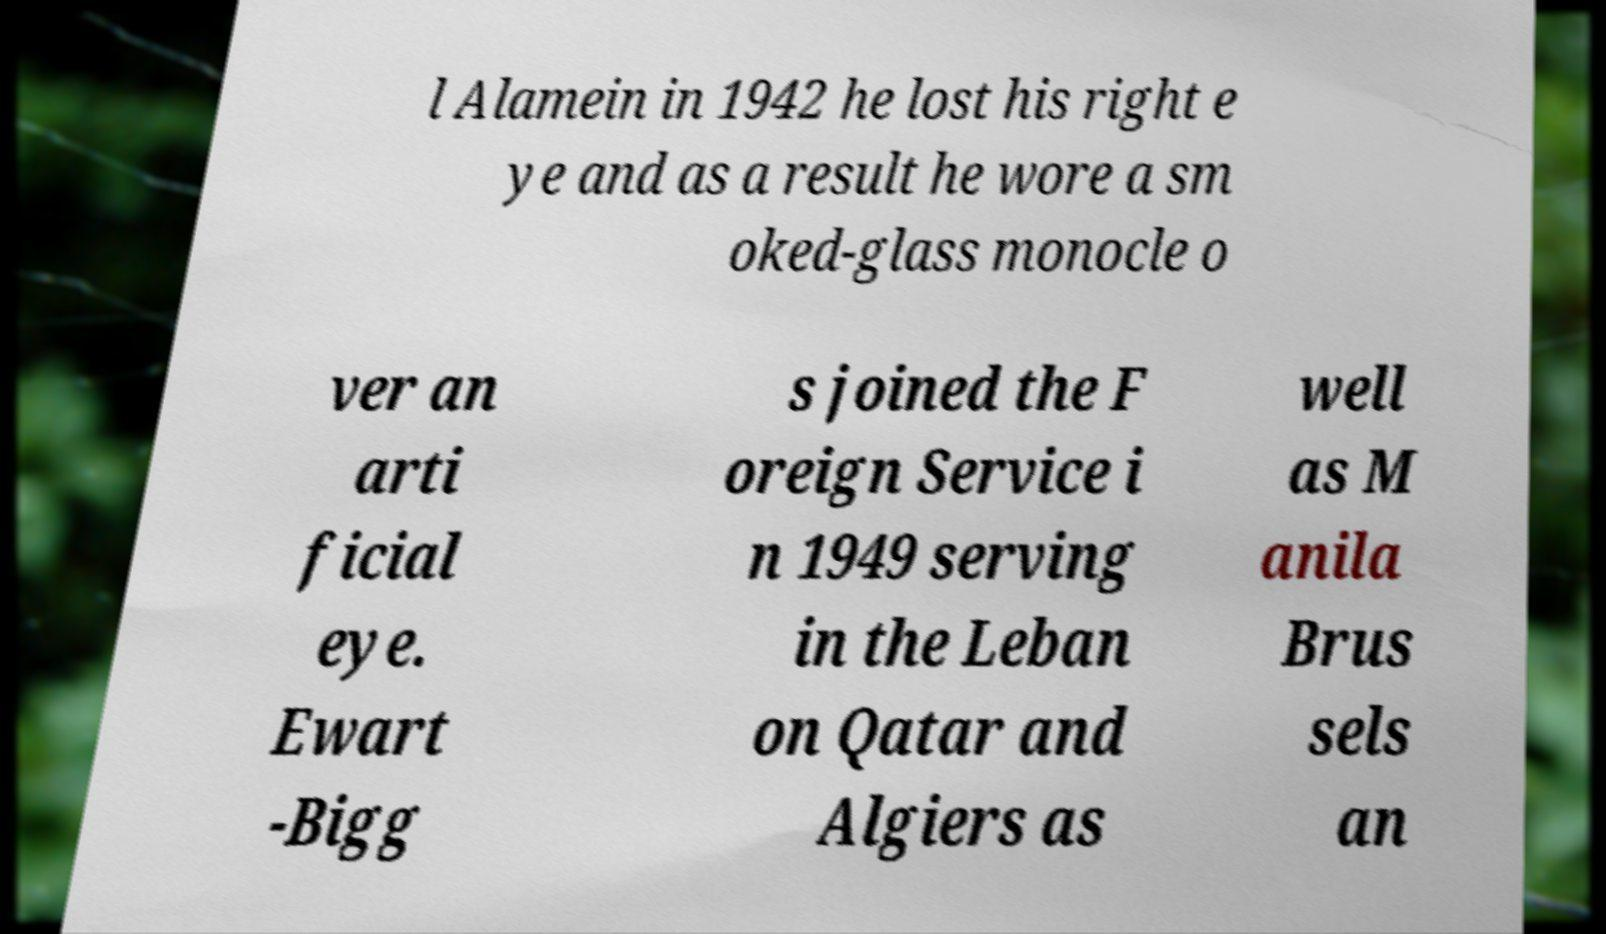Please read and relay the text visible in this image. What does it say? l Alamein in 1942 he lost his right e ye and as a result he wore a sm oked-glass monocle o ver an arti ficial eye. Ewart -Bigg s joined the F oreign Service i n 1949 serving in the Leban on Qatar and Algiers as well as M anila Brus sels an 